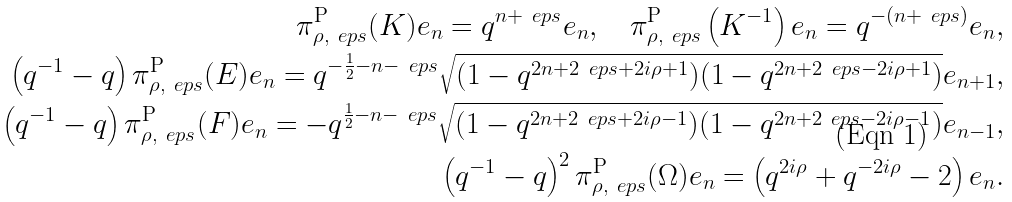Convert formula to latex. <formula><loc_0><loc_0><loc_500><loc_500>\pi ^ { \mathrm P } _ { \rho , \ e p s } ( K ) e _ { n } = q ^ { n + \ e p s } e _ { n } , \quad \pi ^ { \mathrm P } _ { \rho , \ e p s } \left ( K ^ { - 1 } \right ) e _ { n } = q ^ { - ( n + \ e p s ) } e _ { n } , \\ \left ( q ^ { - 1 } - q \right ) \pi ^ { \mathrm P } _ { \rho , \ e p s } ( E ) e _ { n } = q ^ { - \frac { 1 } { 2 } - n - \ e p s } \sqrt { ( 1 - q ^ { 2 n + 2 \ e p s + 2 i \rho + 1 } ) ( 1 - q ^ { 2 n + 2 \ e p s - 2 i \rho + 1 } ) } e _ { n + 1 } , \\ \left ( q ^ { - 1 } - q \right ) \pi ^ { \mathrm P } _ { \rho , \ e p s } ( F ) e _ { n } = - q ^ { \frac { 1 } { 2 } - n - \ e p s } \sqrt { ( 1 - q ^ { 2 n + 2 \ e p s + 2 i \rho - 1 } ) ( 1 - q ^ { 2 n + 2 \ e p s - 2 i \rho - 1 } ) } e _ { n - 1 } , \\ \left ( q ^ { - 1 } - q \right ) ^ { 2 } \pi ^ { \mathrm P } _ { \rho , \ e p s } ( \Omega ) e _ { n } = \left ( q ^ { 2 i \rho } + q ^ { - 2 i \rho } - 2 \right ) e _ { n } .</formula> 